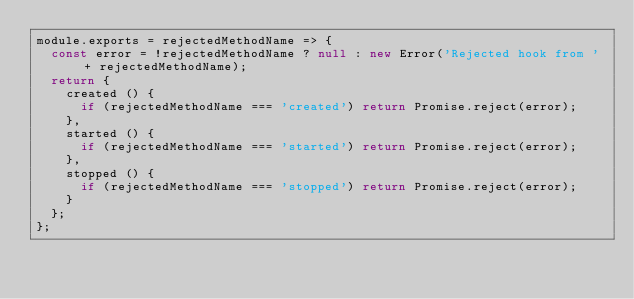Convert code to text. <code><loc_0><loc_0><loc_500><loc_500><_JavaScript_>module.exports = rejectedMethodName => {
  const error = !rejectedMethodName ? null : new Error('Rejected hook from ' + rejectedMethodName);
  return {
    created () {
      if (rejectedMethodName === 'created') return Promise.reject(error);
    },
    started () {
      if (rejectedMethodName === 'started') return Promise.reject(error);
    },
    stopped () {
      if (rejectedMethodName === 'stopped') return Promise.reject(error);
    }
  };
};
</code> 